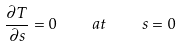<formula> <loc_0><loc_0><loc_500><loc_500>\frac { \partial { T } } { \partial { s } } = 0 \quad a t \quad s = 0</formula> 